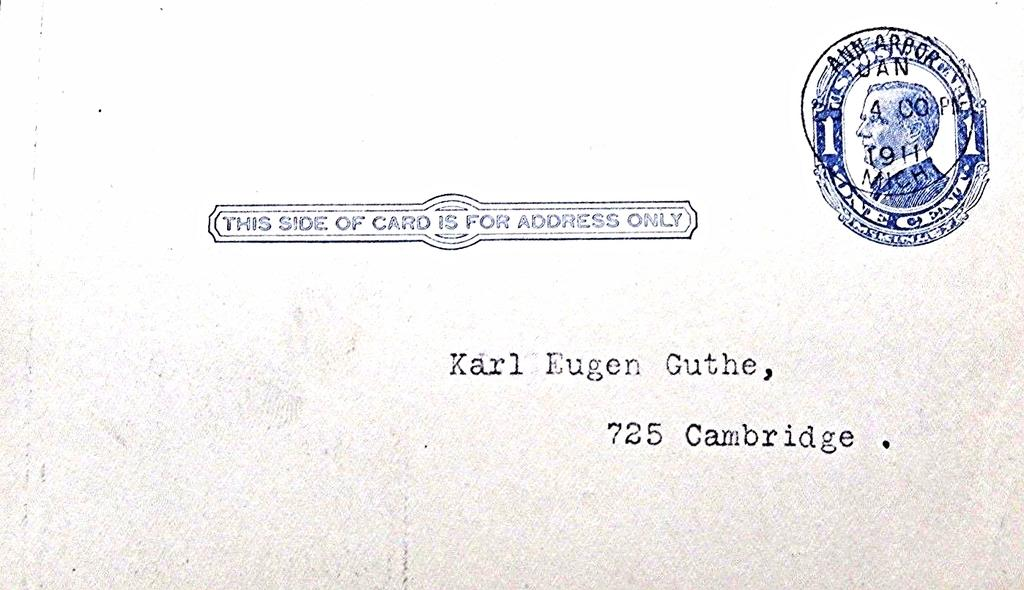<image>
Relay a brief, clear account of the picture shown. the front of a card address to Karl Eugen Guthe 